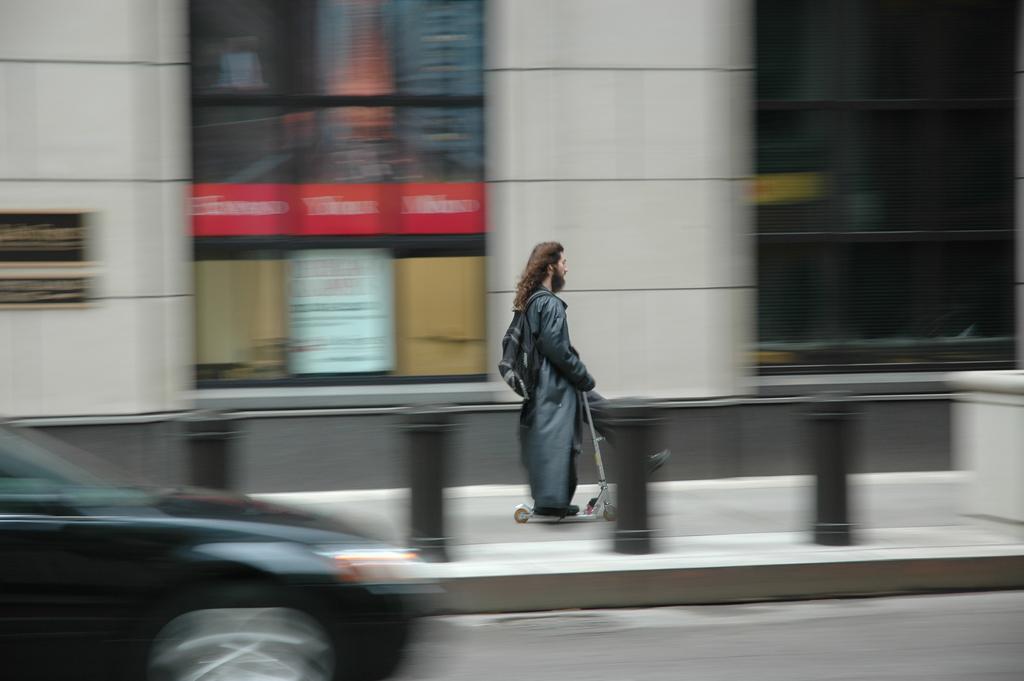How would you summarize this image in a sentence or two? In the image is blur. In the image in the left a car is moving on the road. In the side walk a person is riding a scooter carrying a backpack. In the background there is a building. 